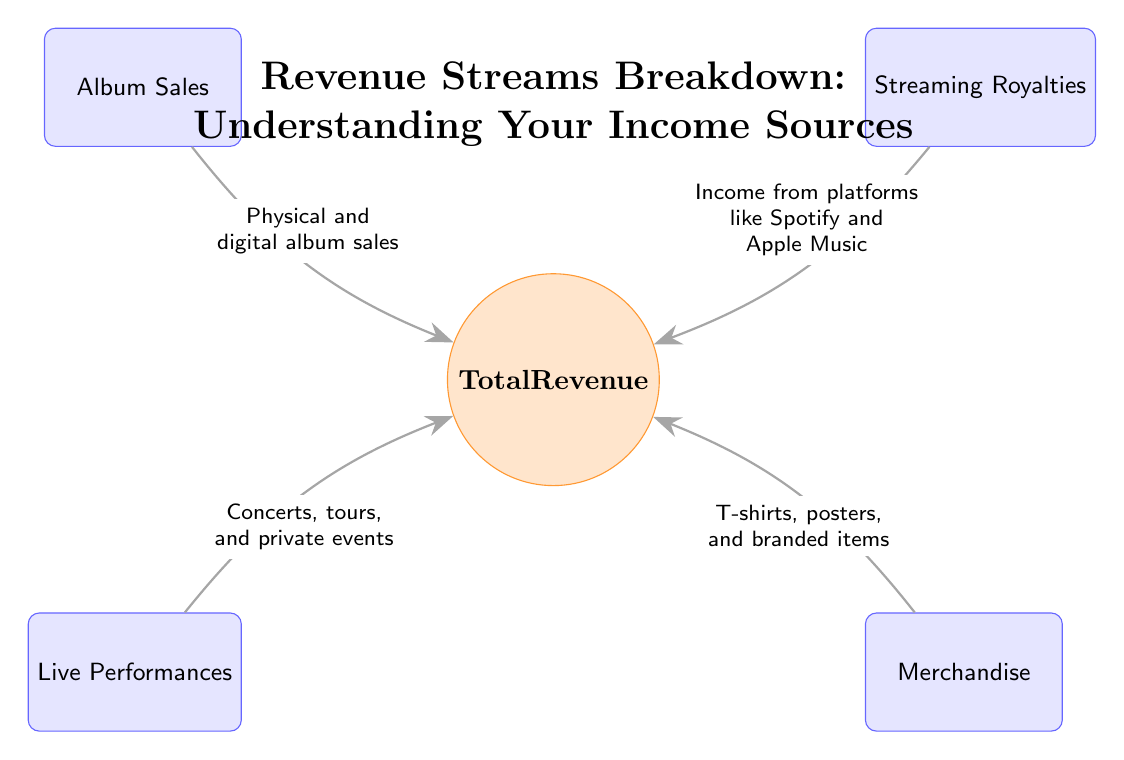What are the four main revenue sources shown in the diagram? The diagram lists four revenue sources: Album Sales, Streaming Royalties, Live Performances, and Merchandise. These sources are displayed as nodes connected to the central node representing Total Revenue.
Answer: Album Sales, Streaming Royalties, Live Performances, Merchandise What type of merchandise can be sold according to the diagram? The diagram indicates that merchandise includes items such as T-shirts, posters, and branded items. This information is labeled on the edge leading to the Merchandise node.
Answer: T-shirts, posters, branded items Which revenue stream is related to income from platforms like Spotify and Apple Music? The Streaming Royalties node is connected to the flow indicating income from these platforms, distinguishing it from the other sources. This connection shows that it is specifically associated with streaming services.
Answer: Streaming Royalties How many edges are present in the diagram? The diagram features four edges that connect each revenue source to the Total Revenue node, illustrating the flow of revenue from each source.
Answer: 4 Which revenue stream contributes to concerts, tours, and private events? The Live Performances node is connected to the central Total Revenue node with a labeled edge that specifically mentions these events, clearly identifying it as the revenue stream in question.
Answer: Live Performances What does the central node represent in the diagram? The central node labeled "Total Revenue" represents the cumulative income from all identified revenue sources, serving as the focal point of the diagram and aggregating the contributions of each source.
Answer: Total Revenue Which edge flows from the Album Sales node? The edge flowing from Album Sales describes it as "Physical and digital album sales," indicating how this source contributes to the overall revenue.
Answer: Physical and digital album sales What are the two lower nodes in the diagram? The lower nodes connected to the Total Revenue node are Live Performances and Merchandise, positioned to reflect their contributions to the overall income structure.
Answer: Live Performances, Merchandise 